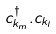Convert formula to latex. <formula><loc_0><loc_0><loc_500><loc_500>c _ { k _ { m } } ^ { \dagger } . c _ { k _ { l } }</formula> 